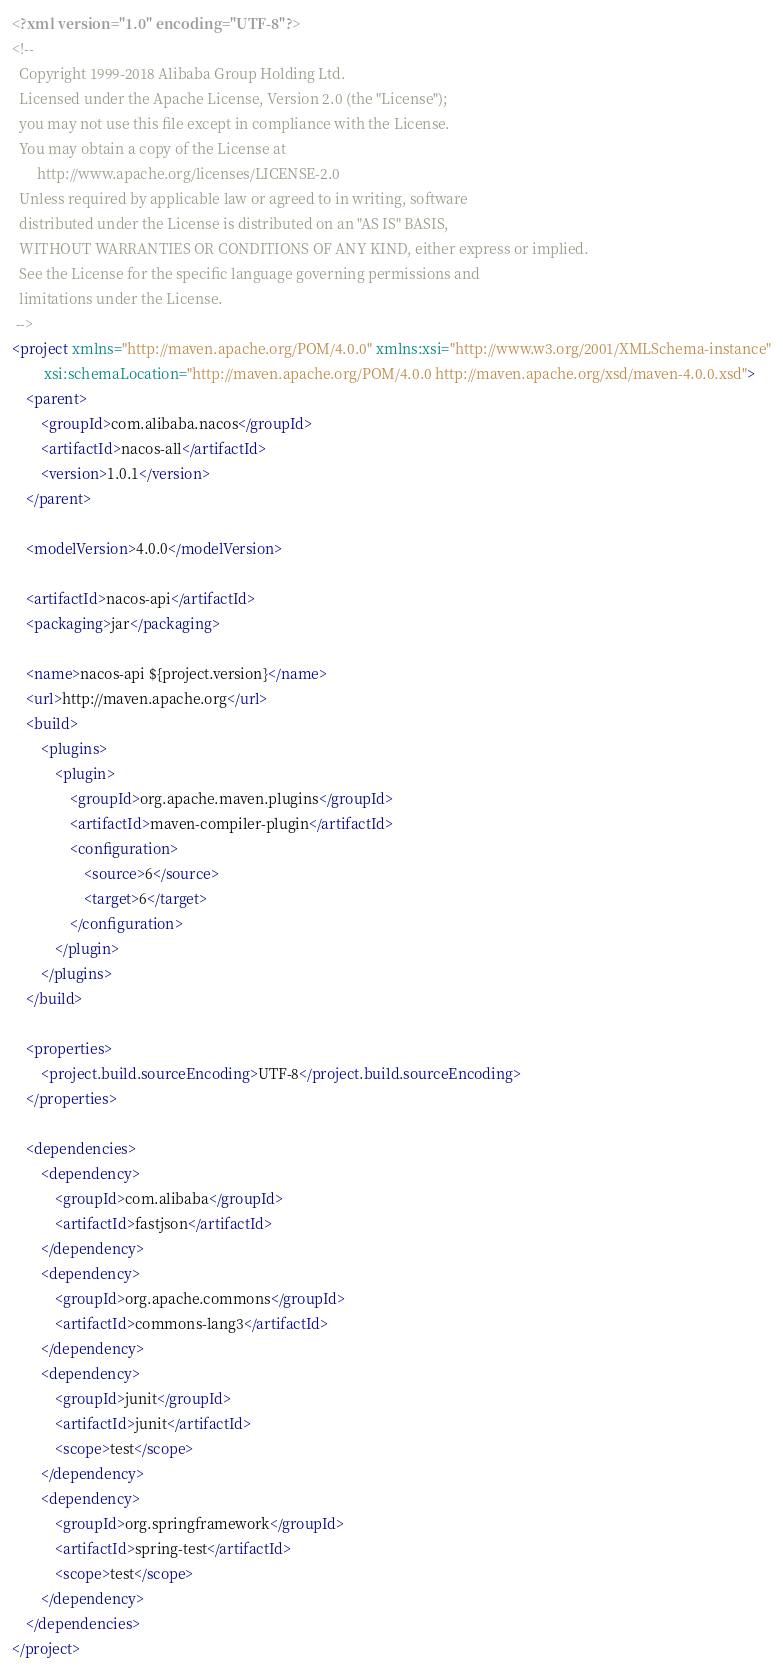Convert code to text. <code><loc_0><loc_0><loc_500><loc_500><_XML_><?xml version="1.0" encoding="UTF-8"?>
<!--
  Copyright 1999-2018 Alibaba Group Holding Ltd.
  Licensed under the Apache License, Version 2.0 (the "License");
  you may not use this file except in compliance with the License.
  You may obtain a copy of the License at
       http://www.apache.org/licenses/LICENSE-2.0
  Unless required by applicable law or agreed to in writing, software
  distributed under the License is distributed on an "AS IS" BASIS,
  WITHOUT WARRANTIES OR CONDITIONS OF ANY KIND, either express or implied.
  See the License for the specific language governing permissions and
  limitations under the License.
 -->
<project xmlns="http://maven.apache.org/POM/4.0.0" xmlns:xsi="http://www.w3.org/2001/XMLSchema-instance"
         xsi:schemaLocation="http://maven.apache.org/POM/4.0.0 http://maven.apache.org/xsd/maven-4.0.0.xsd">
    <parent>
        <groupId>com.alibaba.nacos</groupId>
        <artifactId>nacos-all</artifactId>
        <version>1.0.1</version>
    </parent>

    <modelVersion>4.0.0</modelVersion>

    <artifactId>nacos-api</artifactId>
    <packaging>jar</packaging>

    <name>nacos-api ${project.version}</name>
    <url>http://maven.apache.org</url>
    <build>
        <plugins>
            <plugin>
                <groupId>org.apache.maven.plugins</groupId>
                <artifactId>maven-compiler-plugin</artifactId>
                <configuration>
                    <source>6</source>
                    <target>6</target>
                </configuration>
            </plugin>
        </plugins>
    </build>

    <properties>
        <project.build.sourceEncoding>UTF-8</project.build.sourceEncoding>
    </properties>

    <dependencies>
        <dependency>
            <groupId>com.alibaba</groupId>
            <artifactId>fastjson</artifactId>
        </dependency>
        <dependency>
            <groupId>org.apache.commons</groupId>
            <artifactId>commons-lang3</artifactId>
        </dependency>
        <dependency>
            <groupId>junit</groupId>
            <artifactId>junit</artifactId>
            <scope>test</scope>
        </dependency>
        <dependency>
            <groupId>org.springframework</groupId>
            <artifactId>spring-test</artifactId>
            <scope>test</scope>
        </dependency>
    </dependencies>
</project>
</code> 